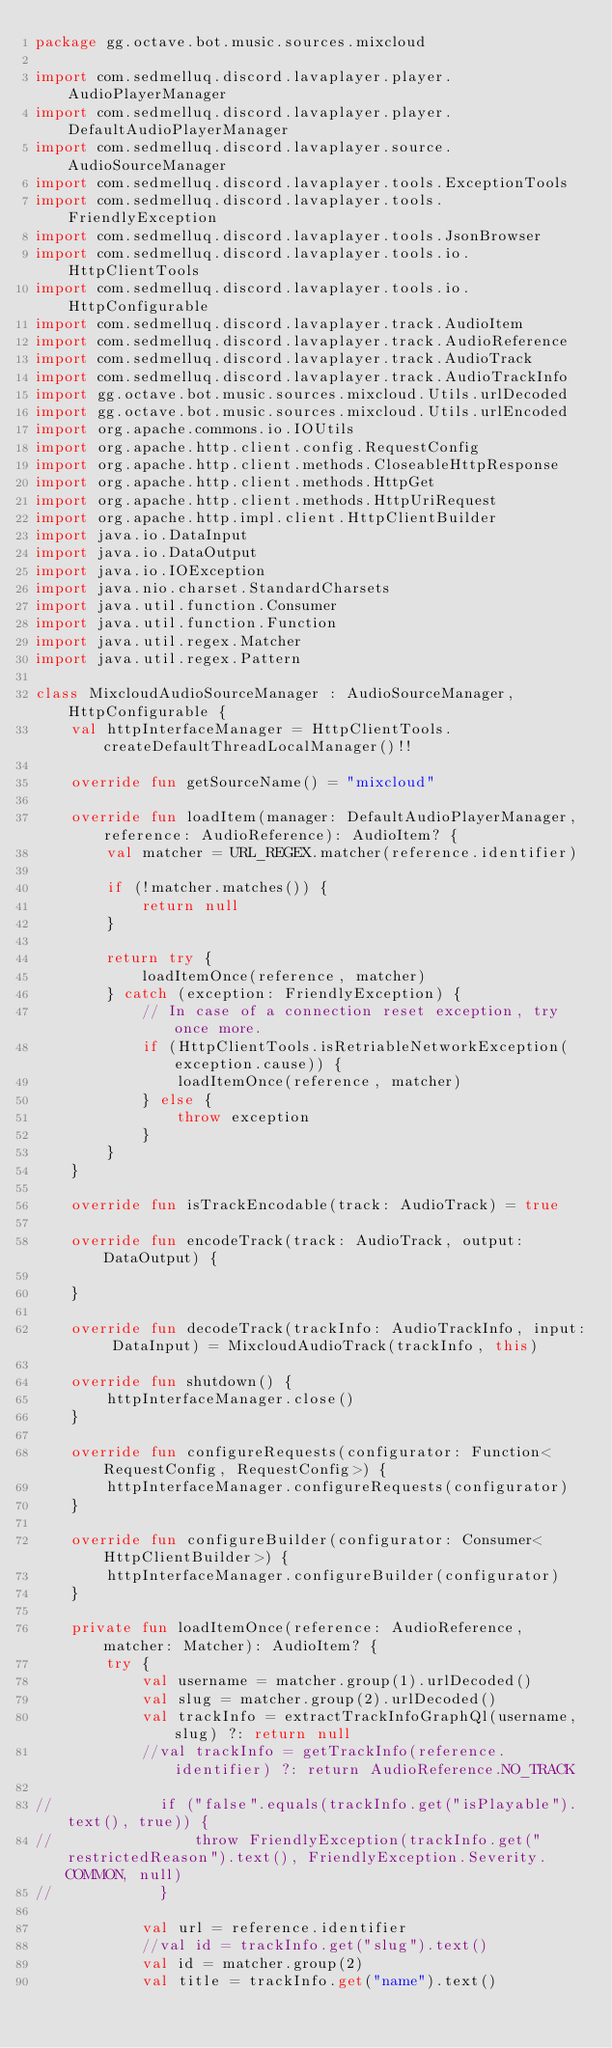Convert code to text. <code><loc_0><loc_0><loc_500><loc_500><_Kotlin_>package gg.octave.bot.music.sources.mixcloud

import com.sedmelluq.discord.lavaplayer.player.AudioPlayerManager
import com.sedmelluq.discord.lavaplayer.player.DefaultAudioPlayerManager
import com.sedmelluq.discord.lavaplayer.source.AudioSourceManager
import com.sedmelluq.discord.lavaplayer.tools.ExceptionTools
import com.sedmelluq.discord.lavaplayer.tools.FriendlyException
import com.sedmelluq.discord.lavaplayer.tools.JsonBrowser
import com.sedmelluq.discord.lavaplayer.tools.io.HttpClientTools
import com.sedmelluq.discord.lavaplayer.tools.io.HttpConfigurable
import com.sedmelluq.discord.lavaplayer.track.AudioItem
import com.sedmelluq.discord.lavaplayer.track.AudioReference
import com.sedmelluq.discord.lavaplayer.track.AudioTrack
import com.sedmelluq.discord.lavaplayer.track.AudioTrackInfo
import gg.octave.bot.music.sources.mixcloud.Utils.urlDecoded
import gg.octave.bot.music.sources.mixcloud.Utils.urlEncoded
import org.apache.commons.io.IOUtils
import org.apache.http.client.config.RequestConfig
import org.apache.http.client.methods.CloseableHttpResponse
import org.apache.http.client.methods.HttpGet
import org.apache.http.client.methods.HttpUriRequest
import org.apache.http.impl.client.HttpClientBuilder
import java.io.DataInput
import java.io.DataOutput
import java.io.IOException
import java.nio.charset.StandardCharsets
import java.util.function.Consumer
import java.util.function.Function
import java.util.regex.Matcher
import java.util.regex.Pattern

class MixcloudAudioSourceManager : AudioSourceManager, HttpConfigurable {
    val httpInterfaceManager = HttpClientTools.createDefaultThreadLocalManager()!!

    override fun getSourceName() = "mixcloud"

    override fun loadItem(manager: DefaultAudioPlayerManager, reference: AudioReference): AudioItem? {
        val matcher = URL_REGEX.matcher(reference.identifier)

        if (!matcher.matches()) {
            return null
        }

        return try {
            loadItemOnce(reference, matcher)
        } catch (exception: FriendlyException) {
            // In case of a connection reset exception, try once more.
            if (HttpClientTools.isRetriableNetworkException(exception.cause)) {
                loadItemOnce(reference, matcher)
            } else {
                throw exception
            }
        }
    }

    override fun isTrackEncodable(track: AudioTrack) = true

    override fun encodeTrack(track: AudioTrack, output: DataOutput) {

    }

    override fun decodeTrack(trackInfo: AudioTrackInfo, input: DataInput) = MixcloudAudioTrack(trackInfo, this)

    override fun shutdown() {
        httpInterfaceManager.close()
    }

    override fun configureRequests(configurator: Function<RequestConfig, RequestConfig>) {
        httpInterfaceManager.configureRequests(configurator)
    }

    override fun configureBuilder(configurator: Consumer<HttpClientBuilder>) {
        httpInterfaceManager.configureBuilder(configurator)
    }

    private fun loadItemOnce(reference: AudioReference, matcher: Matcher): AudioItem? {
        try {
            val username = matcher.group(1).urlDecoded()
            val slug = matcher.group(2).urlDecoded()
            val trackInfo = extractTrackInfoGraphQl(username, slug) ?: return null
            //val trackInfo = getTrackInfo(reference.identifier) ?: return AudioReference.NO_TRACK

//            if ("false".equals(trackInfo.get("isPlayable").text(), true)) {
//                throw FriendlyException(trackInfo.get("restrictedReason").text(), FriendlyException.Severity.COMMON, null)
//            }

            val url = reference.identifier
            //val id = trackInfo.get("slug").text()
            val id = matcher.group(2)
            val title = trackInfo.get("name").text()</code> 